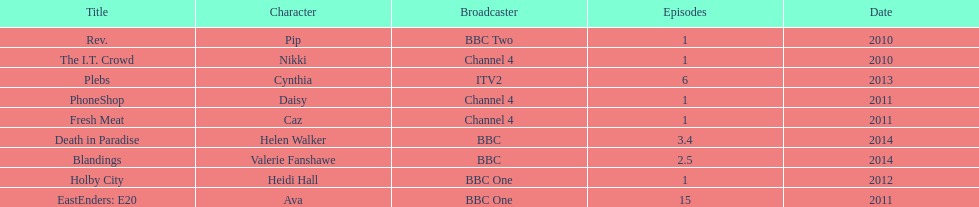How many titles only had one episode? 5. 